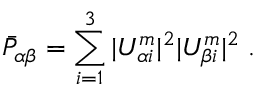<formula> <loc_0><loc_0><loc_500><loc_500>\bar { P } _ { \alpha \beta } = \sum _ { i = 1 } ^ { 3 } | U _ { \alpha i } ^ { m } | ^ { 2 } | U _ { \beta i } ^ { m } | ^ { 2 } \, .</formula> 